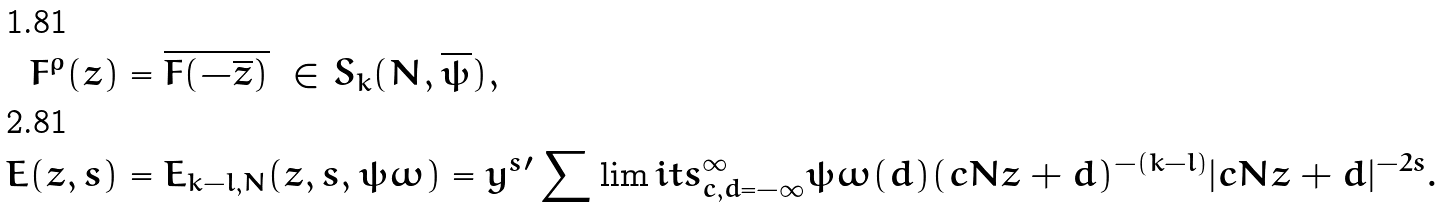<formula> <loc_0><loc_0><loc_500><loc_500>F ^ { \rho } ( z ) & = \overline { F ( - \overline { z } ) } \ \in S _ { k } ( N , \overline { \psi } ) , \\ E ( z , s ) & = E _ { k - l , N } ( z , s , \psi \omega ) = y ^ { s } { ^ { \prime } } \sum \lim i t s _ { c , d = - \infty } ^ { \infty } \psi \omega ( d ) ( c N z + d ) ^ { - ( k - l ) } | c N z + d | ^ { - 2 s } .</formula> 